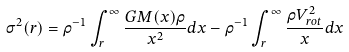<formula> <loc_0><loc_0><loc_500><loc_500>\sigma ^ { 2 } ( r ) = \rho ^ { - 1 } \int _ { r } ^ { \infty } \frac { G M ( x ) \rho } { x ^ { 2 } } d x - \rho ^ { - 1 } \int _ { r } ^ { \infty } \frac { \rho V _ { r o t } ^ { 2 } } { x } d x</formula> 